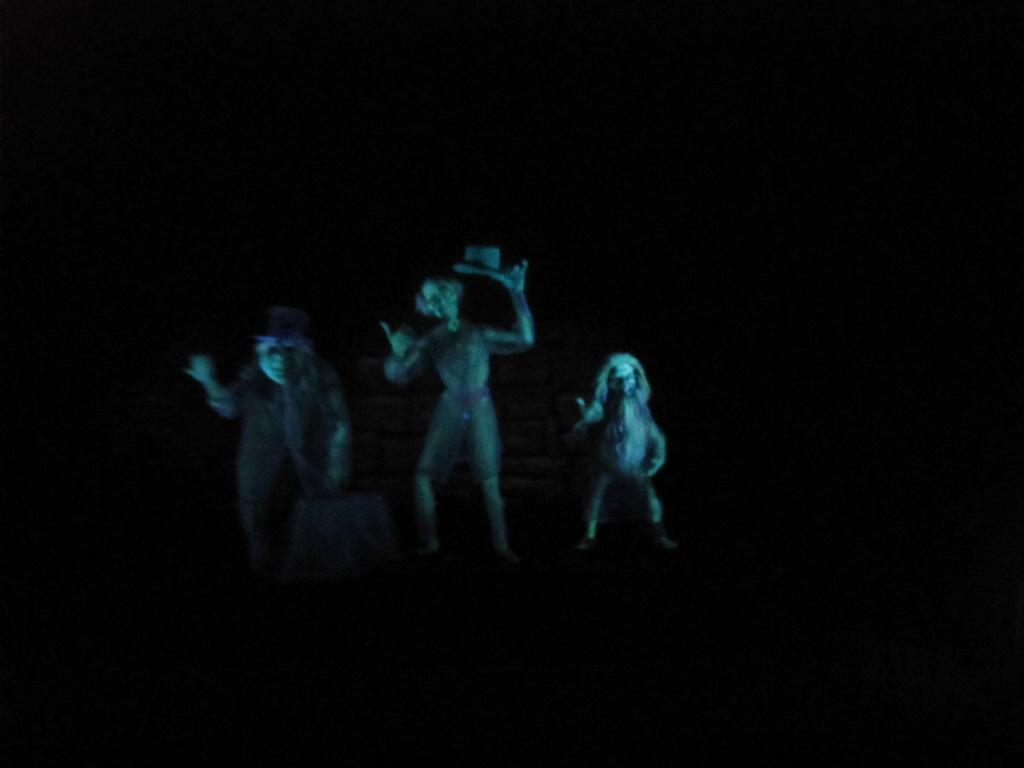What type of objects are depicted in the image? There are statues of persons in the image. Can you describe the setting in which the statues are located? The statues are standing in darkness. Despite the darkness, what part of the statues is illuminated? Light is falling on the faces of the statues. What type of flowers can be seen growing around the statues in the image? There are no flowers present in the image; the statues are standing in darkness with light falling on their faces. 